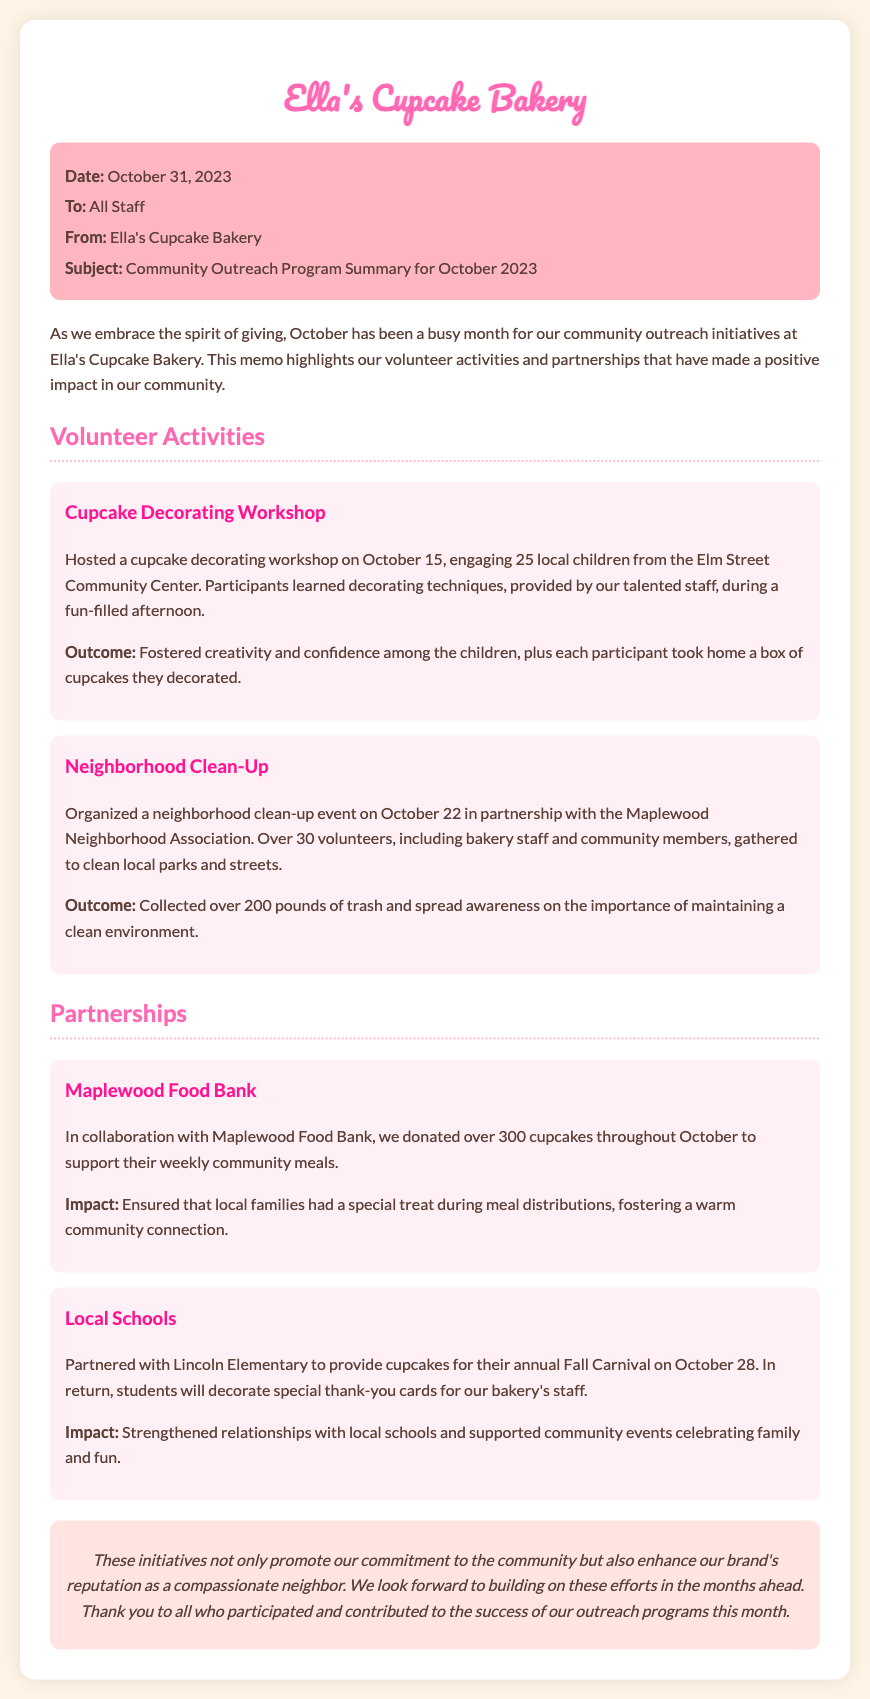What was the date of the community outreach program summary? The date is mentioned in the header of the document, which states it is October 31, 2023.
Answer: October 31, 2023 How many children participated in the cupcake decorating workshop? The document specifies that 25 local children from the Elm Street Community Center participated in the workshop.
Answer: 25 What was the outcome of the neighborhood clean-up event? The document notes that the outcome was the collection of over 200 pounds of trash and the raising of awareness about maintaining a clean environment.
Answer: Over 200 pounds of trash Who did Ella's Cupcake Bakery partner with to provide cupcakes for the Fall Carnival? The document states that they partnered with Lincoln Elementary for this event.
Answer: Lincoln Elementary How many cupcakes were donated to the Maplewood Food Bank throughout October? The document specifies that over 300 cupcakes were donated to the Maplewood Food Bank during October.
Answer: Over 300 cupcakes What kind of cards did students from Lincoln Elementary create for the bakery's staff? The document mentions that students decorated special thank-you cards for the bakery's staff.
Answer: Thank-you cards What kind of impact did the partnership with Maplewood Food Bank have? The document states that the impact was ensuring local families received a special treat during meal distributions, fostering community connection.
Answer: Fostered a warm community connection What event was held on October 22? The document specifies that a neighborhood clean-up event was organized on this date in partnership with the Maplewood Neighborhood Association.
Answer: Neighborhood clean-up What is highlighted at the end of the memo? The conclusion emphasizes the bakery's commitment to the community and the enhancement of its brand's reputation as a compassionate neighbor.
Answer: Commitment to the community 